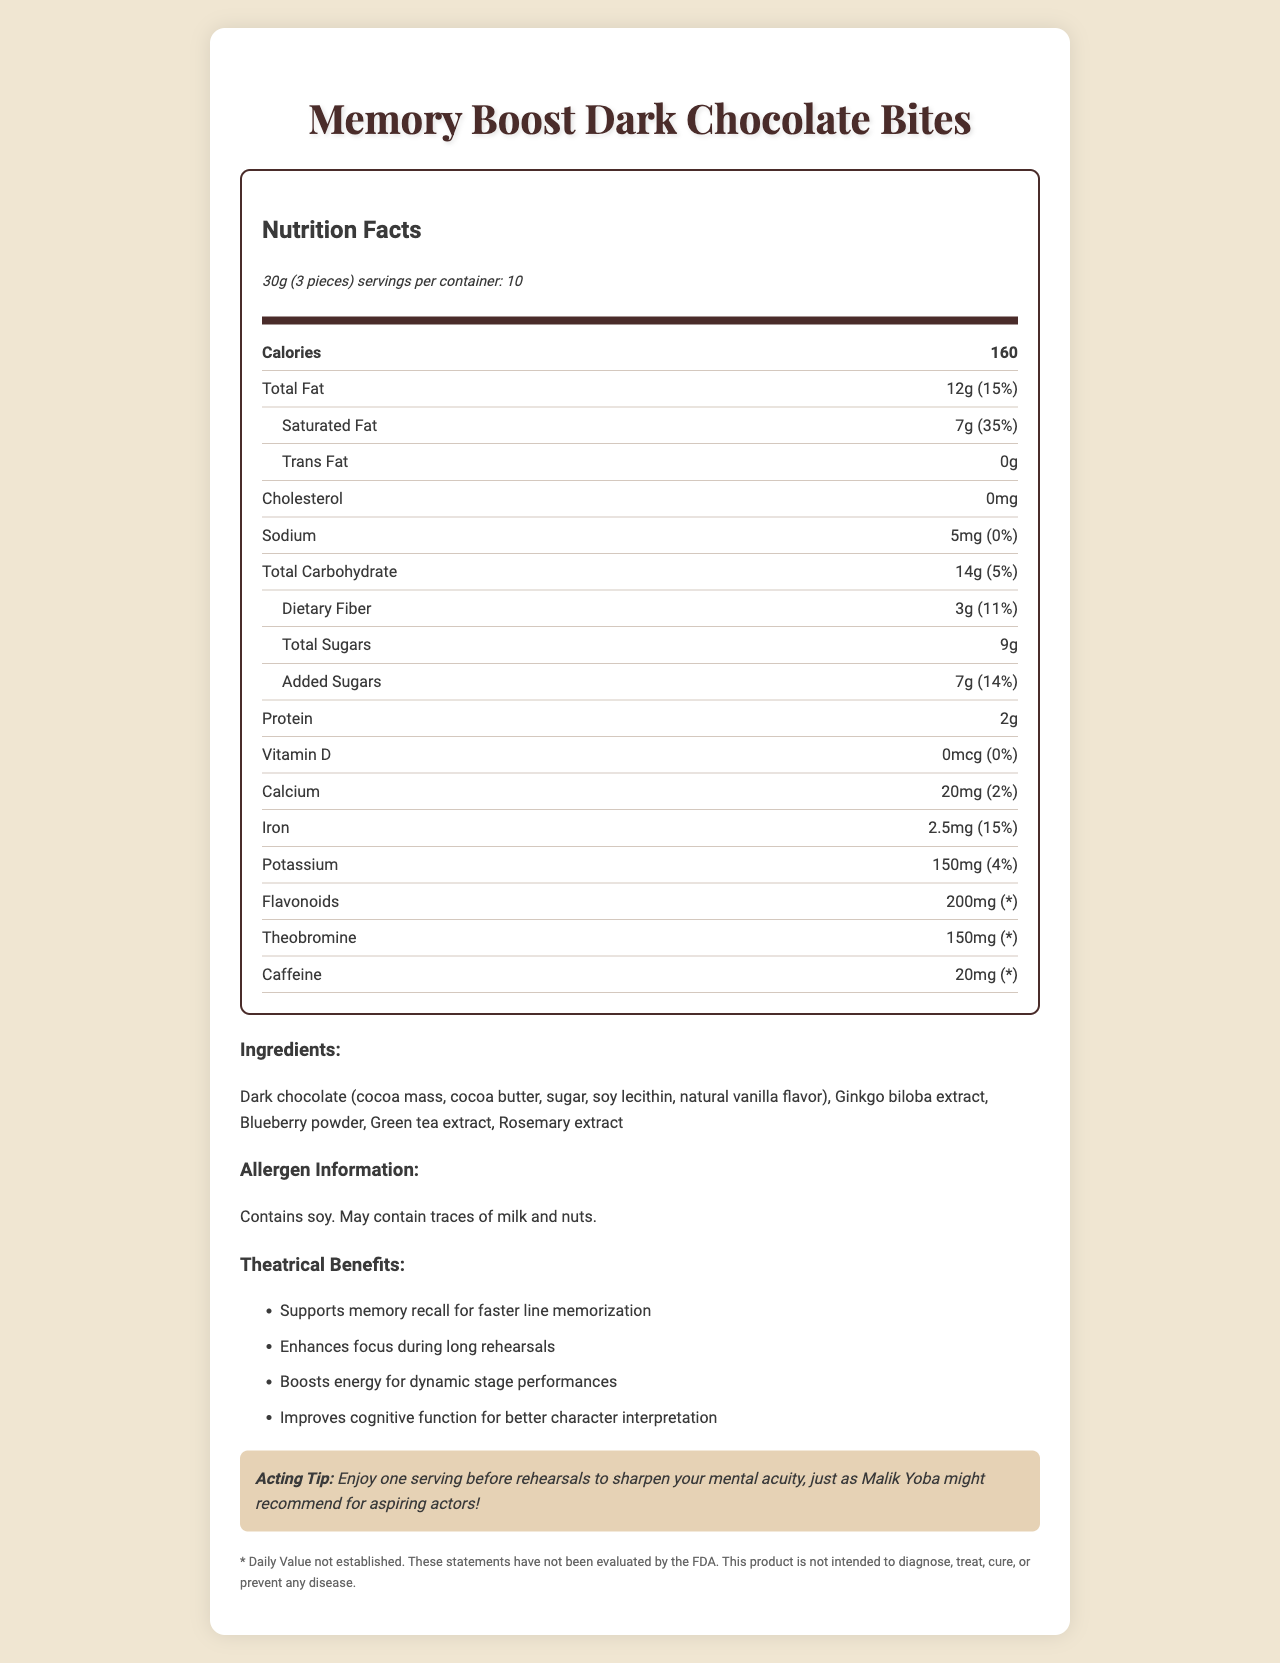what is the serving size for the Memory Boost Dark Chocolate Bites? The serving size is explicitly stated as "30g (3 pieces)" under the Nutrition Facts header.
Answer: 30g (3 pieces) how many calories are there per serving? The document lists "Calories" and the corresponding value is "160."
Answer: 160 what is the percentage of daily value for saturated fat? Under the Total Fat section, the amount for Saturated Fat is given as "7g" and the daily value is "35%".
Answer: 35% what ingredients are included in the Memory Boost Dark Chocolate Bites? The Ingredients section lists all these items.
Answer: Dark chocolate (cocoa mass, cocoa butter, sugar, soy lecithin, natural vanilla flavor), Ginkgo biloba extract, Blueberry powder, Green tea extract, Rosemary extract what are the theatrical benefits mentioned for these dark chocolate bites? The Theatrical Benefits section lists these four points.
Answer: Supports memory recall for faster line memorization, Enhances focus during long rehearsals, Boosts energy for dynamic stage performances, Improves cognitive function for better character interpretation how much protein is present in one serving of Memory Boost Dark Chocolate Bites? The document lists "Protein" as having "2g" per serving.
Answer: 2g how much iron can you get from one serving of these dark chocolate bites? In the nutrient list, "Iron" is specified as "2.5mg."
Answer: 2.5mg is the product suitable for people with soy allergies? The Allergen Information section states "Contains soy. May contain traces of milk and nuts."
Answer: No What percentage of the daily value for dietary fiber is in one serving? A. 5% B. 11% C. 14% The Dietary Fiber amount is listed as "3g" which corresponds to "11%" daily value.
Answer: B. 11% What is the primary purpose of this product as stated in the theatrical benefits? A. Boosts energy for performances B. Enhances focus C. Supports memory recall D. Improves cognitive function The first and primary benefit listed is "Supports memory recall for faster line memorization."
Answer: C. Supports memory recall Does this product contain caffeine? The nutrient row for Caffeine states it contains "20mg."
Answer: Yes Summarize the main idea of this nutrition facts label. The document aims to provide a detailed overview of the nutritional composition and cognitive benefits of the Memory Boost Dark Chocolate Bites, targeting actors and performers who need mental sharpness.
Answer: The Memory Boost Dark Chocolate Bites are a nutritional snack designed to enhance various cognitive functions important for actors. They contain high levels of antioxidants and nutrients like flavonoids, theobromine, and caffeine, which help with memory recall, focus, and overall performance. Additionally, the label provides detailed nutritional information and points out the allergens present in the product. What is the cost per serving of the product? The document does not provide any information regarding the price or cost per serving of the Memory Boost Dark Chocolate Bites.
Answer: Cannot be determined 